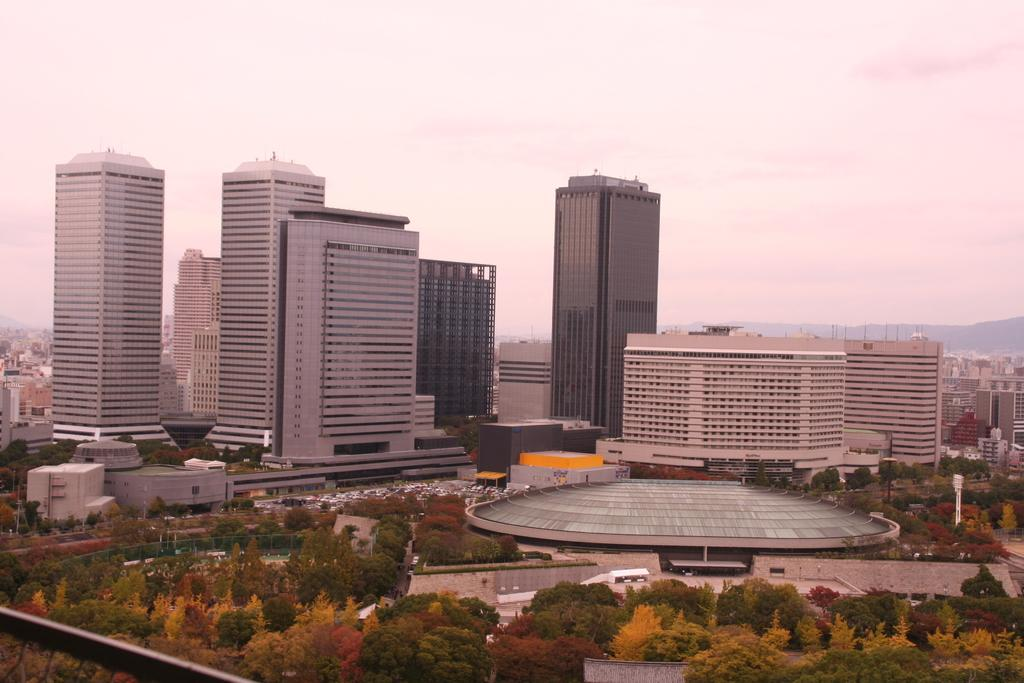What type of natural elements can be seen in the image? There are trees in the image. What type of man-made structures are present in the image? There are buildings in the image. What type of geographical features can be seen in the image? There are hills in the image. Can you see a balloon floating in the sky in the image? There is no balloon present in the image. Is there a mark on the trees indicating a specific location? There is no mark on the trees visible in the image. 